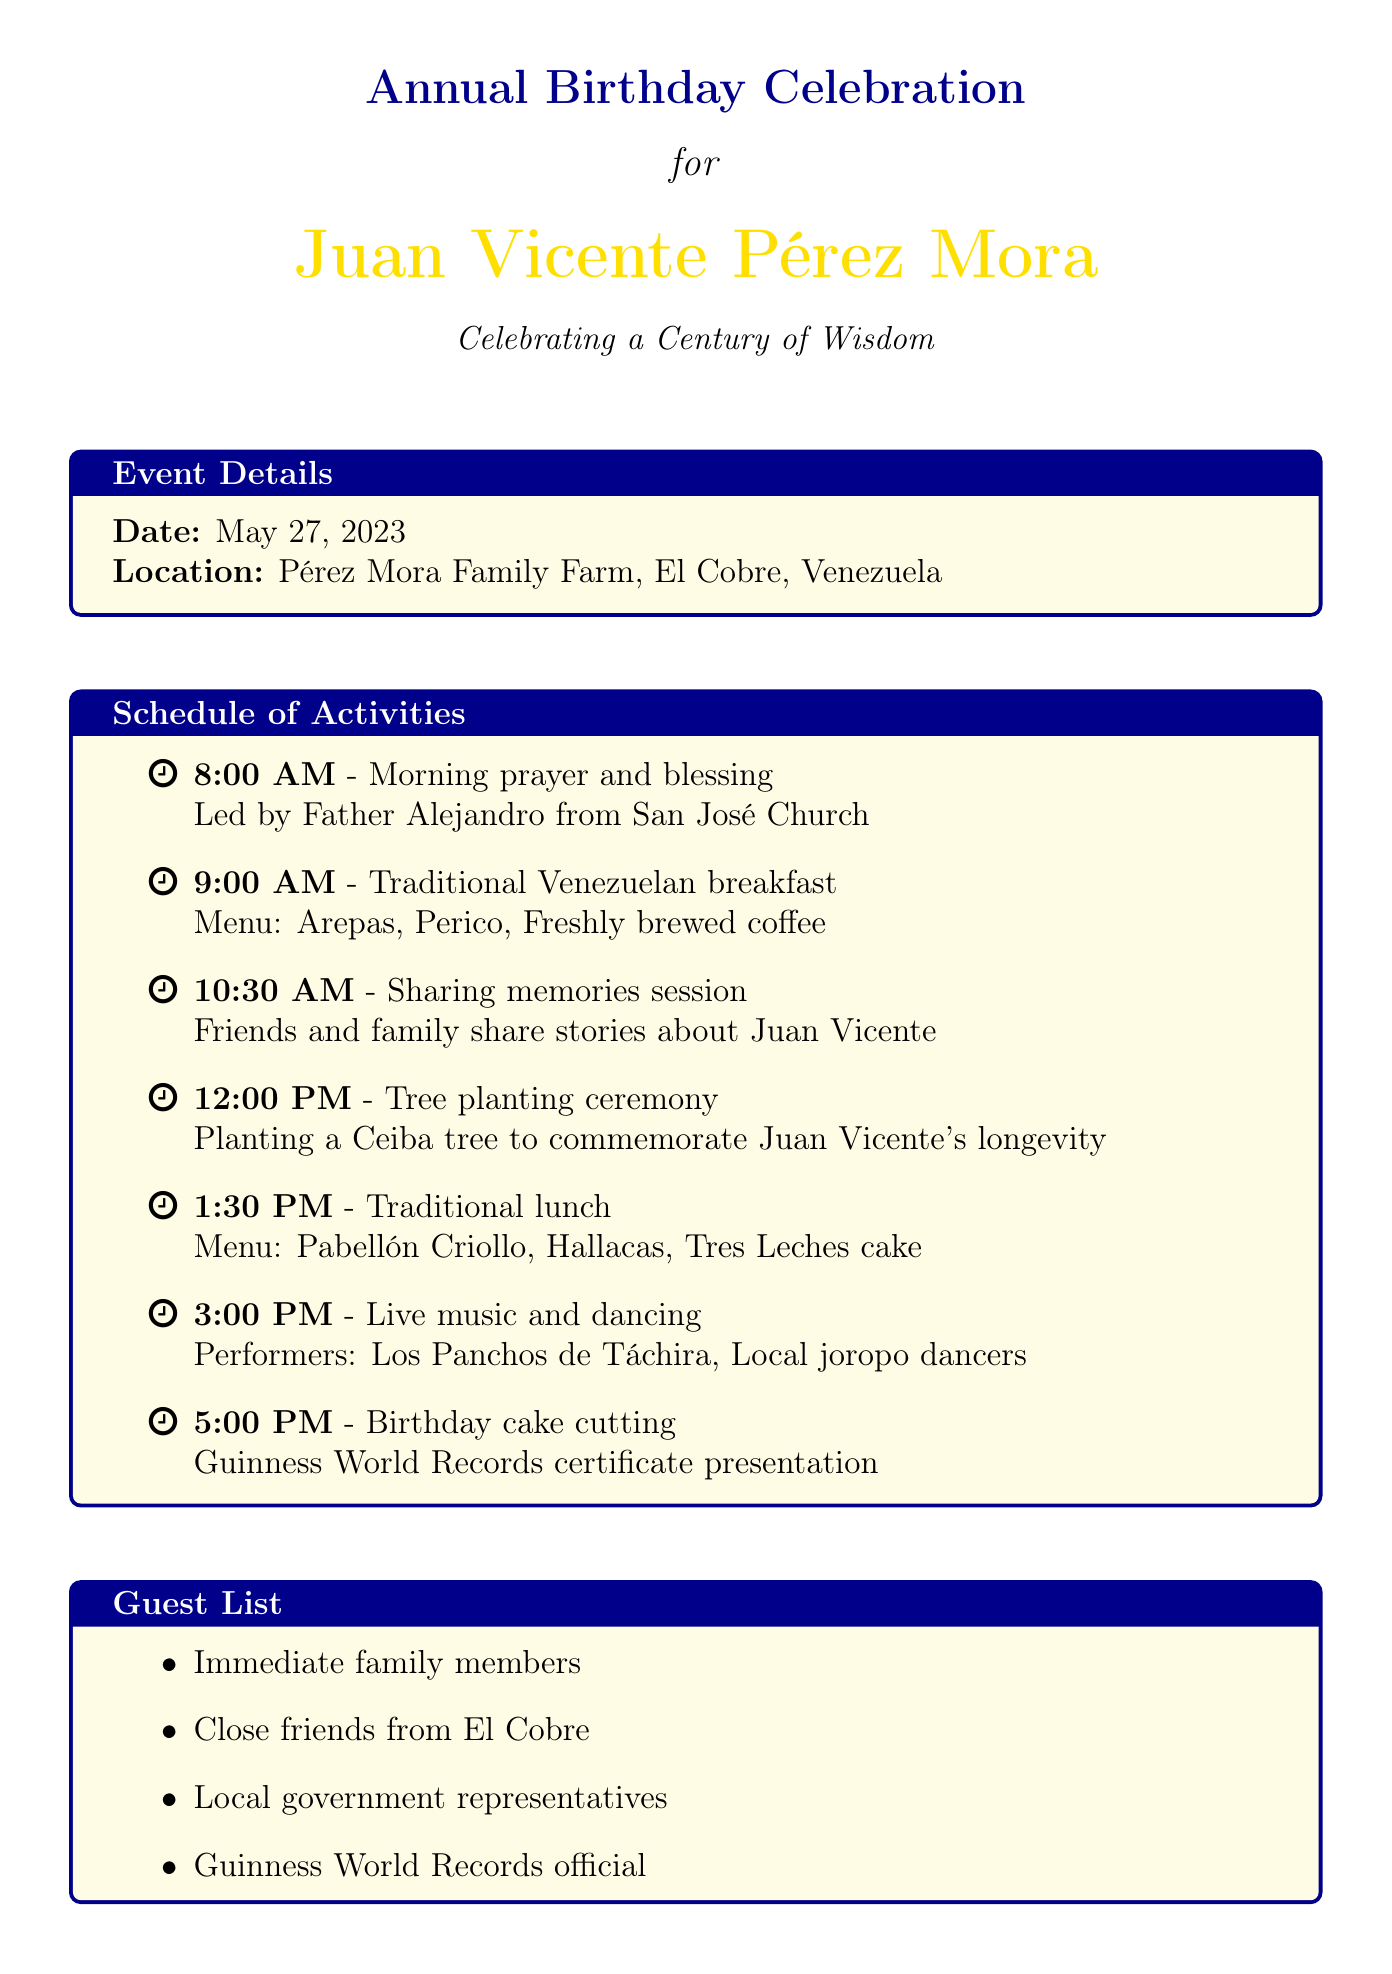What is the date of the celebration? The date of the celebration is explicitly mentioned in the document as May 27, 2023.
Answer: May 27, 2023 Where is the celebration located? The document specifies the location of the event as Pérez Mora Family Farm, El Cobre, Venezuela.
Answer: Pérez Mora Family Farm, El Cobre, Venezuela What is the theme of the celebration? The theme of the celebration is provided in the document as "Celebrating a Century of Wisdom".
Answer: Celebrating a Century of Wisdom Who will lead the morning prayer? The document mentions that Father Alejandro from San José Church will lead the morning prayer and blessing.
Answer: Father Alejandro What time is the birthday cake cutting scheduled? The time for the birthday cake cutting is indicated as 5:00 PM in the schedule of activities.
Answer: 5:00 PM Which meal is served at 1:30 PM? According to the schedule, the traditional lunch is served at 1:30 PM.
Answer: Traditional lunch How many types of decorations are listed? The document lists three types of decorations in the section about decorations.
Answer: Three Who is invited from the local government? The guest list includes local government representatives as part of the invitations.
Answer: Local government representatives What is one special consideration mentioned? The document states several special considerations, one of them being to ensure plenty of shade and water available.
Answer: Plenty of shade and water available 